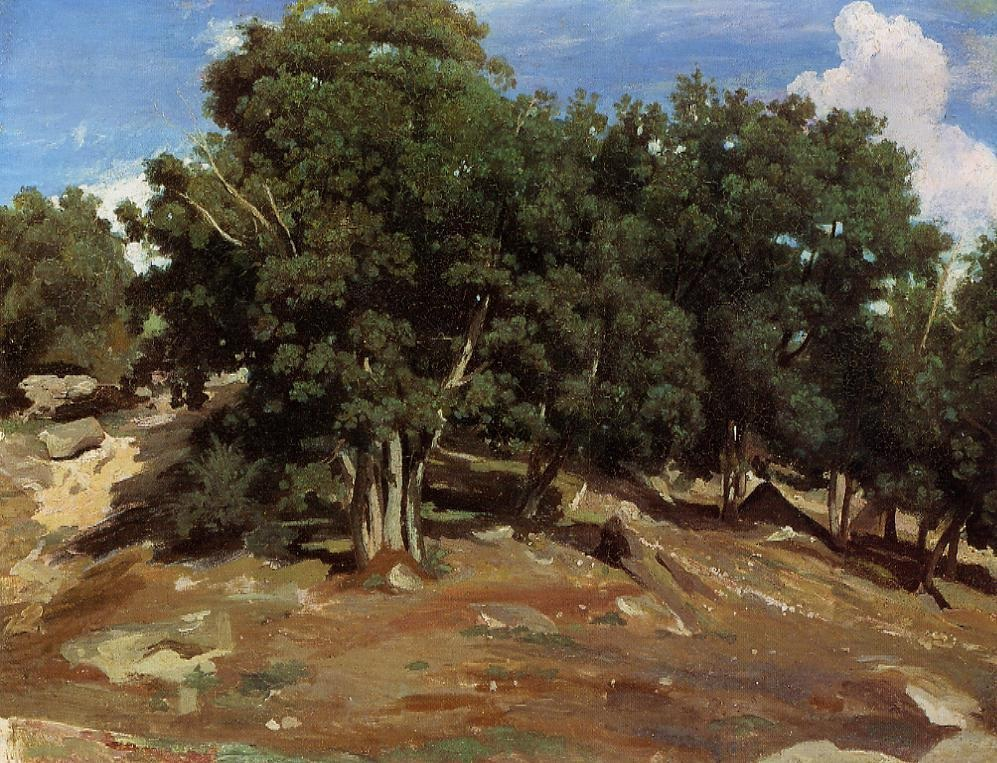If you were an artist planning to paint this scene, what techniques and materials would you use to capture its essence? To capture the essence of this landscape, I would use oil paints to take advantage of their rich, vibrant colors and the ability to create depth with layers. I would employ the Impressionist technique of loose, expressive brushstrokes to convey the dynamic interplay of light and shadow on the trees and rocks. A palette knife would help in adding texture to the rocky hillside, creating a rugged, tactile feel. Additionally, soft brushes would be ideal for blending the colors of the sky and leaves, creating a mosaic of greens and blues that suggest movement and life. This combination of techniques and materials would effectively capture both the tranquility and the raw beauty of the landscape.  Given this scene, what kind of wildlife might inhabit this area? This scene suggests a habitat rich with diverse wildlife. You might find deer grazing peacefully among the trees and small mammals, like squirrels and rabbits, scurrying around the rocky terrain. Birds of various species would likely inhabit the area as well, their songs filling the air. Insect life, such as butterflies and bees, would be abundant, contributing to the ecosystem by pollinating the plants. The presence of a nearby stream, suggested by the lushness of the trees, might indicate frogs and other amphibians, while the sound of rustling leaves could hint at the movements of larger animals like foxes or even a curious bear exploring the hillside. 